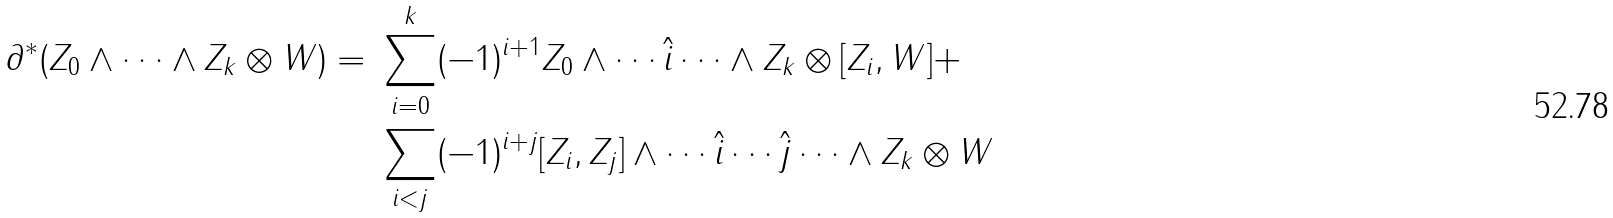<formula> <loc_0><loc_0><loc_500><loc_500>\partial ^ { * } ( Z _ { 0 } \wedge \dots \wedge Z _ { k } \otimes W ) = \ & \sum _ { i = 0 } ^ { k } ( - 1 ) ^ { i + 1 } Z _ { 0 } \wedge \cdots \hat { i } \cdots \wedge Z _ { k } \otimes [ Z _ { i } , W ] + \\ & \sum _ { i < j } ( - 1 ) ^ { i + j } [ Z _ { i } , Z _ { j } ] \wedge \cdots \hat { i } \cdots \hat { j } \cdots \wedge Z _ { k } \otimes W</formula> 